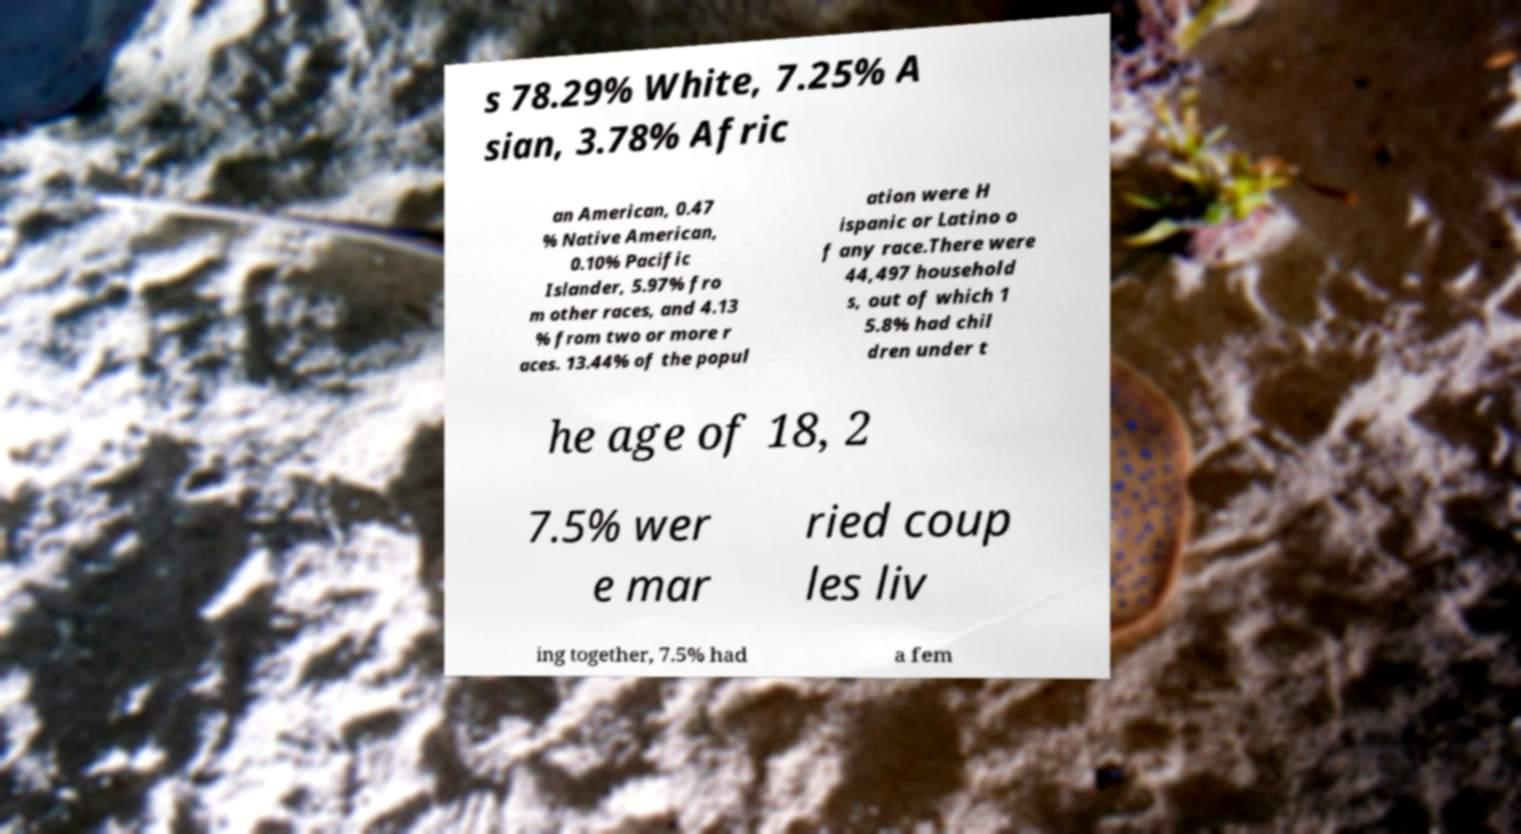What messages or text are displayed in this image? I need them in a readable, typed format. s 78.29% White, 7.25% A sian, 3.78% Afric an American, 0.47 % Native American, 0.10% Pacific Islander, 5.97% fro m other races, and 4.13 % from two or more r aces. 13.44% of the popul ation were H ispanic or Latino o f any race.There were 44,497 household s, out of which 1 5.8% had chil dren under t he age of 18, 2 7.5% wer e mar ried coup les liv ing together, 7.5% had a fem 